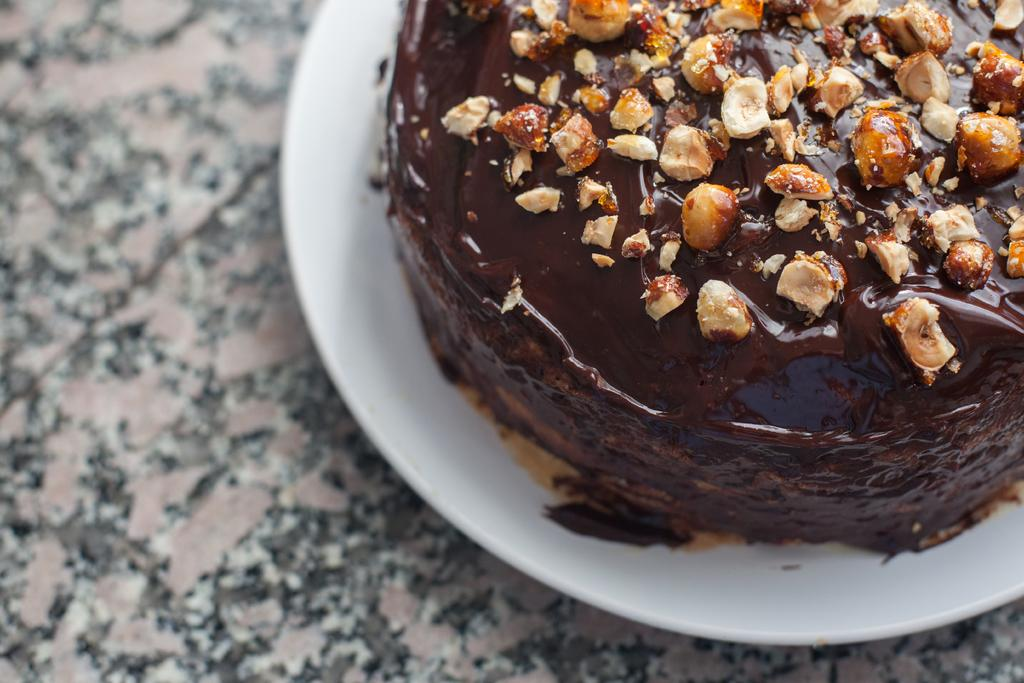What object is on the floor in the image? There is a plate on the floor in the image. What is on the plate? There is food on the plate. What type of design can be seen on the honey in the image? There is no honey present in the image, and therefore no design can be observed. 